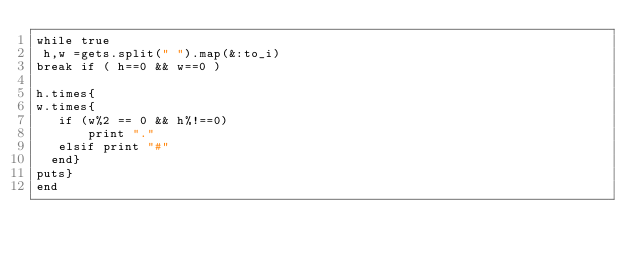<code> <loc_0><loc_0><loc_500><loc_500><_Ruby_>while true
 h,w =gets.split(" ").map(&:to_i)
break if ( h==0 && w==0 )

h.times{
w.times{
   if (w%2 == 0 && h%!==0)
       print "."
   elsif print "#"
  end}
puts}
end
       </code> 